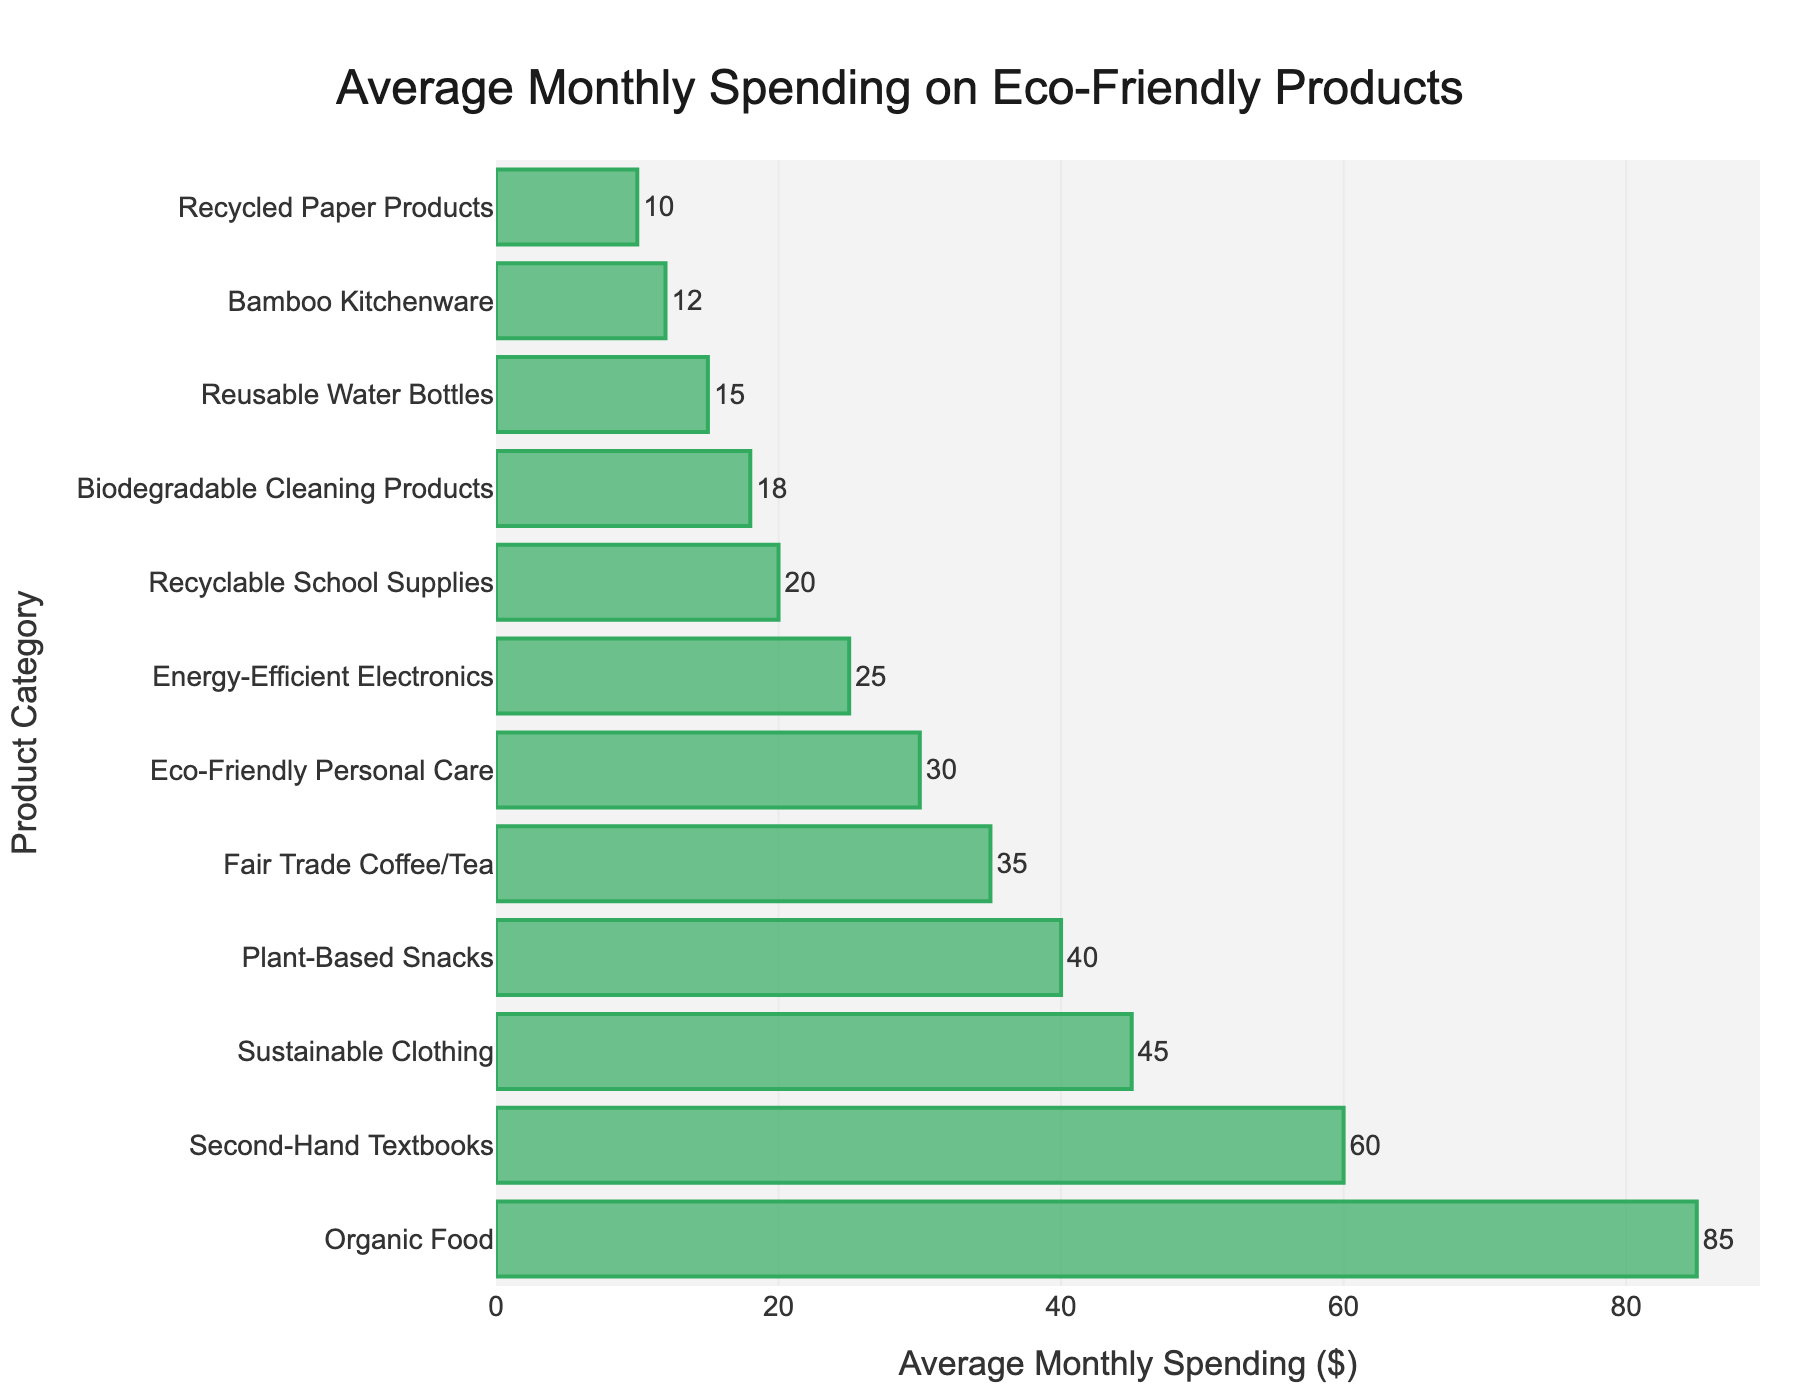What is the category with the highest average monthly spending? By looking at the height of the bars, the category with the highest average monthly spending has the tallest bar. The "Organic Food" category has the highest bar.
Answer: Organic Food What is the total average monthly spending on Sustainable Clothing and Eco-Friendly Personal Care? To find the total average monthly spending, sum the values for these categories: Sustainable Clothing ($45) + Eco-Friendly Personal Care ($30) = $75.
Answer: $75 Which category has a lower average monthly spending, Reusable Water Bottles or Fair Trade Coffee/Tea? By comparing the heights of the two bars, Reusable Water Bottles ($15) has a lower average monthly spending than Fair Trade Coffee/Tea ($35).
Answer: Reusable Water Bottles What is the difference in average monthly spending between Second-Hand Textbooks and Energy-Efficient Electronics? Subtract the average monthly spending of Energy-Efficient Electronics ($25) from that of Second-Hand Textbooks ($60): $60 - $25 = $35.
Answer: $35 What are the second and third highest spending categories? By observing the heights of the bars and sorting them in descending order, the second and third highest spending categories are Second-Hand Textbooks ($60) and Sustainable Clothing ($45), respectively.
Answer: Second-Hand Textbooks, Sustainable Clothing What is the combined average monthly spending on Biodegradable Cleaning Products, Recycled Paper Products, and Bamboo Kitchenware? Sum the average monthly spending for these categories: Biodegradable Cleaning Products ($18) + Recycled Paper Products ($10) + Bamboo Kitchenware ($12) = $40.
Answer: $40 Is the spending on Plant-Based Snacks higher or lower than Sustainable Clothing? By comparing the heights of the bars, the spending on Plant-Based Snacks ($40) is slightly lower than Sustainable Clothing ($45).
Answer: Lower What is the median average monthly spending across all categories? To find the median, first list the spending in ascending order: [$10, $12, $15, $18, $20, $25, $30, $35, $40, $45, $60, $85]. The median is the average of the 6th and 7th values: ($25 + $30) / 2 = $27.50.
Answer: $27.50 How much more is spent on Organic Food compared to Reusable Water Bottles? Subtract the spending on Reusable Water Bottles ($15) from the spending on Organic Food ($85): $85 - $15 = $70.
Answer: $70 